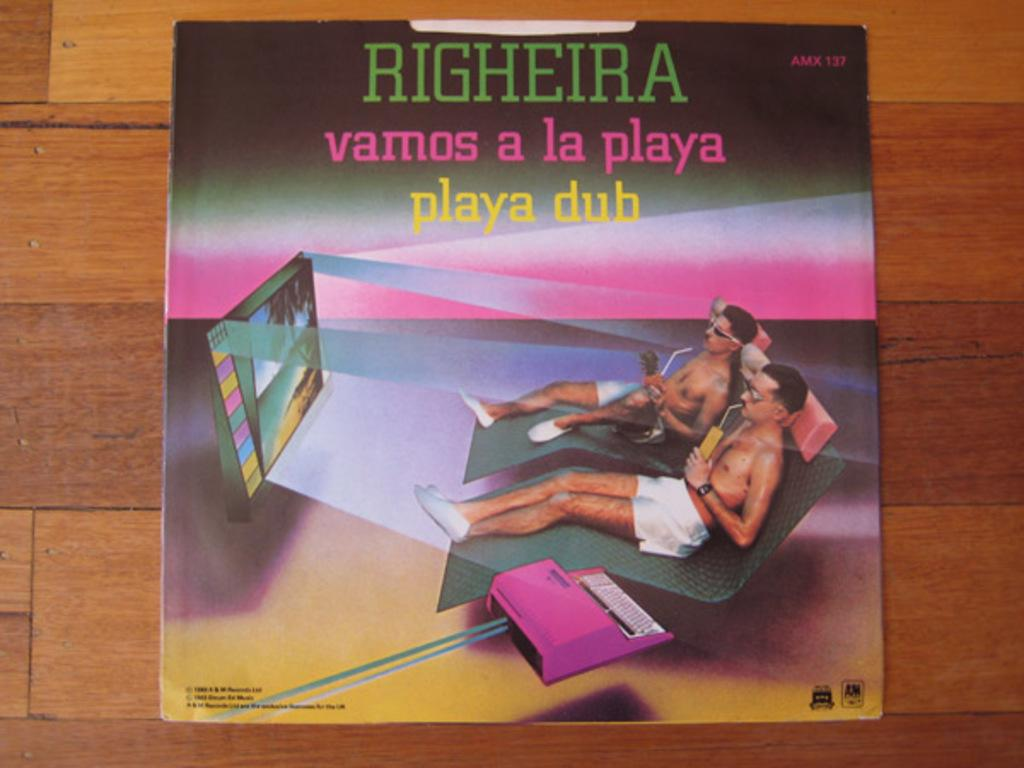Provide a one-sentence caption for the provided image. A CD cover for Righeira vamos a la playa. 